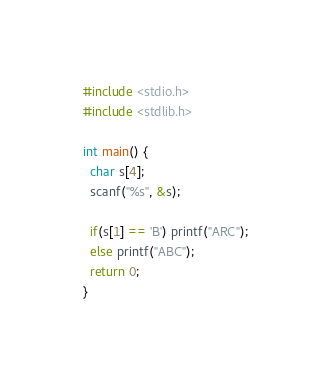<code> <loc_0><loc_0><loc_500><loc_500><_C_>#include <stdio.h>
#include <stdlib.h>

int main() {
  char s[4];
  scanf("%s", &s);

  if(s[1] == 'B') printf("ARC");
  else printf("ABC");
  return 0;
}
</code> 